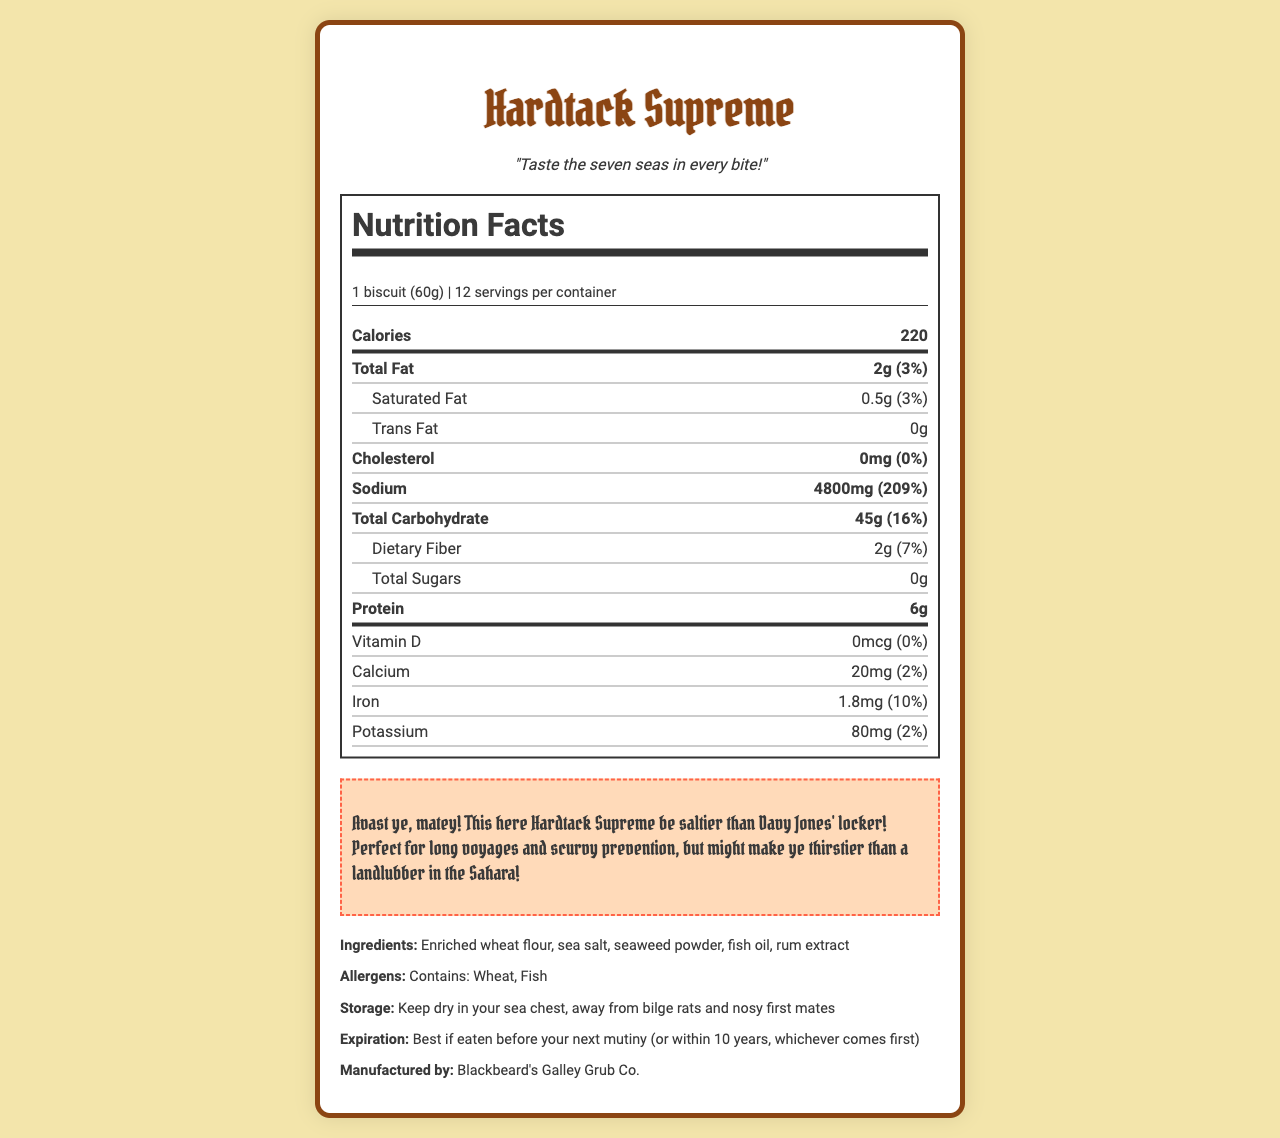What is the serving size for Hardtack Supreme? The serving size is clearly specified at the beginning of the nutrition label.
Answer: 1 biscuit (60g) How many servings are there per container? The nutrition label states that there are 12 servings per container.
Answer: 12 How many calories does one biscuit of Hardtack Supreme contain? The calories per serving are listed as 220.
Answer: 220 What is the daily value percentage of sodium in one serving? The nutrition label lists the daily value percentage of sodium as 209%.
Answer: 209% Which ingredient is not in Hardtack Supreme? A. Sea salt B. Sugar C. Seaweed powder D. Fish oil The ingredient list includes sea salt, seaweed powder, and fish oil but not sugar.
Answer: B What company manufactures Hardtack Supreme? The manufacturer is listed at the end of the document.
Answer: Blackbeard's Galley Grub Co. Does Hardtack Supreme contain any vitamin D? The nutrition label states there is 0mcg of Vitamin D, which is 0% of the daily value.
Answer: No How much protein does one serving of Hardtack Supreme provide? The protein content is listed as 6g per serving.
Answer: 6g Which statement is true about Hardtack Supreme based on the pirate warning? A. It has a low sodium content B. It is good for scurvy prevention C. It is made for short voyages The pirate warning mentions that it is perfect for long voyages and scurvy prevention.
Answer: B What is the expiration guideline for Hardtack Supreme? The expiration information is given as "best if eaten before your next mutiny (or within 10 years, whichever comes first)".
Answer: Best if eaten before your next mutiny (or within 10 years, whichever comes first) Can you store Hardtack Supreme in a damp place? The storage instructions specify to keep it dry in your sea chest, away from bilge rats and nosy first mates.
Answer: No What fish-related ingredient is in Hardtack Supreme? The ingredients list mentions fish oil.
Answer: Fish oil Summarize the nutritional information and features of Hardtack Supreme. The summary encapsulates the main nutritional values, ingredients, and the intended use as described in the document.
Answer: Hardtack Supreme is a high-calorie, high-sodium biscuit with 220 calories and 4800mg of sodium per serving, representing 209% of the daily value for sodium. It also contains 2g of fat, 45g of carbohydrates, 2g of dietary fiber, no sugars, and 6g of protein. Key ingredients include enriched wheat flour, sea salt, seaweed powder, and fish oil. It's made by Blackbeard's Galley Grub Co., and is intended for long voyages and scurvy prevention. What is the specific total carbohydrate content in one serving of Hardtack Supreme? The nutrition label lists the total carbohydrates as 45g per serving.
Answer: 45g Who designed the nutrition facts label? The document does not provide any information about who designed the nutrition facts label.
Answer: Cannot be determined 